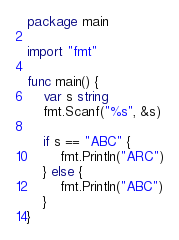Convert code to text. <code><loc_0><loc_0><loc_500><loc_500><_Go_>package main

import "fmt"

func main() {
	var s string
	fmt.Scanf("%s", &s)

	if s == "ABC" {
		fmt.Println("ARC")
	} else {
		fmt.Println("ABC")
	}
}
</code> 